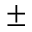Convert formula to latex. <formula><loc_0><loc_0><loc_500><loc_500>\pm</formula> 